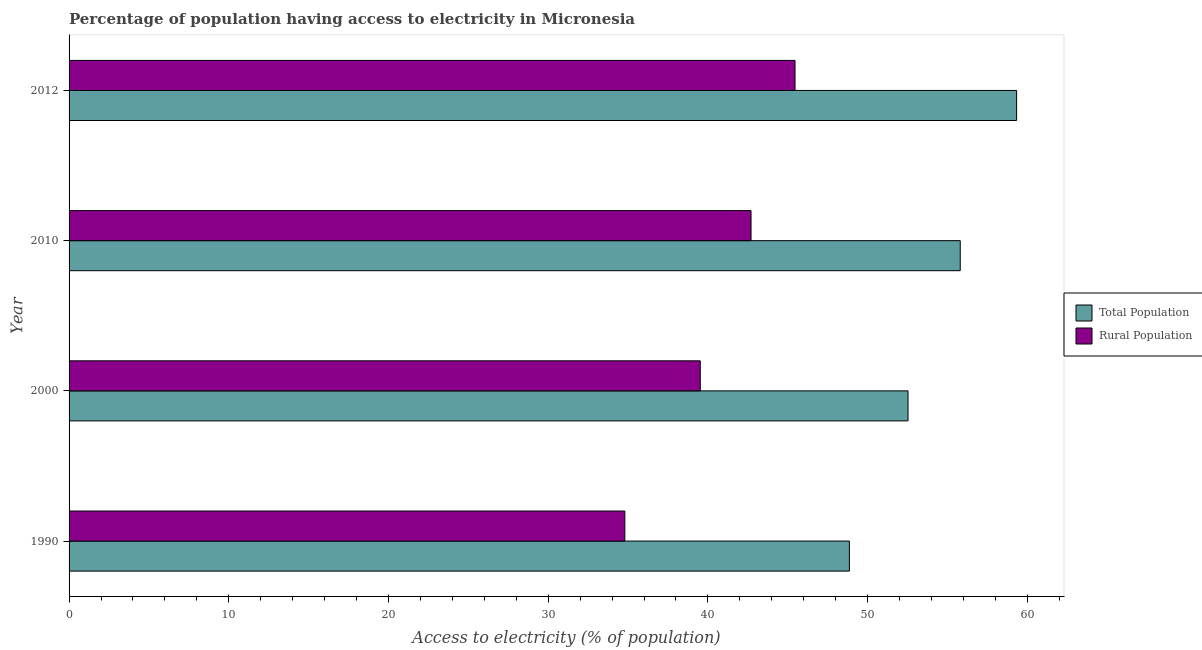How many different coloured bars are there?
Make the answer very short. 2. How many groups of bars are there?
Keep it short and to the point. 4. Are the number of bars on each tick of the Y-axis equal?
Offer a very short reply. Yes. How many bars are there on the 1st tick from the bottom?
Your answer should be very brief. 2. What is the label of the 4th group of bars from the top?
Your answer should be very brief. 1990. What is the percentage of population having access to electricity in 2012?
Offer a terse response. 59.33. Across all years, what is the maximum percentage of rural population having access to electricity?
Offer a very short reply. 45.45. Across all years, what is the minimum percentage of rural population having access to electricity?
Keep it short and to the point. 34.8. What is the total percentage of rural population having access to electricity in the graph?
Your answer should be compact. 162.47. What is the difference between the percentage of population having access to electricity in 2000 and that in 2010?
Provide a succinct answer. -3.27. What is the difference between the percentage of population having access to electricity in 2000 and the percentage of rural population having access to electricity in 2012?
Make the answer very short. 7.08. What is the average percentage of population having access to electricity per year?
Keep it short and to the point. 54.13. In the year 2012, what is the difference between the percentage of population having access to electricity and percentage of rural population having access to electricity?
Keep it short and to the point. 13.87. In how many years, is the percentage of population having access to electricity greater than 12 %?
Your answer should be compact. 4. What is the ratio of the percentage of population having access to electricity in 1990 to that in 2012?
Your response must be concise. 0.82. Is the percentage of rural population having access to electricity in 2000 less than that in 2012?
Provide a succinct answer. Yes. What is the difference between the highest and the second highest percentage of population having access to electricity?
Your response must be concise. 3.53. What is the difference between the highest and the lowest percentage of population having access to electricity?
Make the answer very short. 10.47. What does the 1st bar from the top in 1990 represents?
Offer a terse response. Rural Population. What does the 2nd bar from the bottom in 2012 represents?
Keep it short and to the point. Rural Population. How many bars are there?
Make the answer very short. 8. How many years are there in the graph?
Make the answer very short. 4. Are the values on the major ticks of X-axis written in scientific E-notation?
Your response must be concise. No. Where does the legend appear in the graph?
Ensure brevity in your answer.  Center right. How many legend labels are there?
Offer a terse response. 2. What is the title of the graph?
Your answer should be compact. Percentage of population having access to electricity in Micronesia. Does "Taxes" appear as one of the legend labels in the graph?
Give a very brief answer. No. What is the label or title of the X-axis?
Provide a short and direct response. Access to electricity (% of population). What is the label or title of the Y-axis?
Provide a succinct answer. Year. What is the Access to electricity (% of population) of Total Population in 1990?
Your response must be concise. 48.86. What is the Access to electricity (% of population) in Rural Population in 1990?
Offer a very short reply. 34.8. What is the Access to electricity (% of population) of Total Population in 2000?
Ensure brevity in your answer.  52.53. What is the Access to electricity (% of population) in Rural Population in 2000?
Offer a very short reply. 39.52. What is the Access to electricity (% of population) of Total Population in 2010?
Your answer should be very brief. 55.8. What is the Access to electricity (% of population) in Rural Population in 2010?
Offer a terse response. 42.7. What is the Access to electricity (% of population) of Total Population in 2012?
Give a very brief answer. 59.33. What is the Access to electricity (% of population) of Rural Population in 2012?
Give a very brief answer. 45.45. Across all years, what is the maximum Access to electricity (% of population) in Total Population?
Your answer should be very brief. 59.33. Across all years, what is the maximum Access to electricity (% of population) in Rural Population?
Offer a very short reply. 45.45. Across all years, what is the minimum Access to electricity (% of population) of Total Population?
Your response must be concise. 48.86. Across all years, what is the minimum Access to electricity (% of population) of Rural Population?
Your answer should be compact. 34.8. What is the total Access to electricity (% of population) of Total Population in the graph?
Ensure brevity in your answer.  216.52. What is the total Access to electricity (% of population) of Rural Population in the graph?
Your answer should be compact. 162.47. What is the difference between the Access to electricity (% of population) of Total Population in 1990 and that in 2000?
Provide a succinct answer. -3.67. What is the difference between the Access to electricity (% of population) in Rural Population in 1990 and that in 2000?
Provide a short and direct response. -4.72. What is the difference between the Access to electricity (% of population) in Total Population in 1990 and that in 2010?
Give a very brief answer. -6.94. What is the difference between the Access to electricity (% of population) of Rural Population in 1990 and that in 2010?
Offer a very short reply. -7.9. What is the difference between the Access to electricity (% of population) in Total Population in 1990 and that in 2012?
Keep it short and to the point. -10.47. What is the difference between the Access to electricity (% of population) in Rural Population in 1990 and that in 2012?
Provide a succinct answer. -10.66. What is the difference between the Access to electricity (% of population) in Total Population in 2000 and that in 2010?
Make the answer very short. -3.27. What is the difference between the Access to electricity (% of population) in Rural Population in 2000 and that in 2010?
Your answer should be very brief. -3.18. What is the difference between the Access to electricity (% of population) of Total Population in 2000 and that in 2012?
Give a very brief answer. -6.8. What is the difference between the Access to electricity (% of population) of Rural Population in 2000 and that in 2012?
Make the answer very short. -5.93. What is the difference between the Access to electricity (% of population) in Total Population in 2010 and that in 2012?
Make the answer very short. -3.53. What is the difference between the Access to electricity (% of population) of Rural Population in 2010 and that in 2012?
Provide a short and direct response. -2.75. What is the difference between the Access to electricity (% of population) in Total Population in 1990 and the Access to electricity (% of population) in Rural Population in 2000?
Keep it short and to the point. 9.34. What is the difference between the Access to electricity (% of population) of Total Population in 1990 and the Access to electricity (% of population) of Rural Population in 2010?
Offer a terse response. 6.16. What is the difference between the Access to electricity (% of population) of Total Population in 1990 and the Access to electricity (% of population) of Rural Population in 2012?
Keep it short and to the point. 3.4. What is the difference between the Access to electricity (% of population) in Total Population in 2000 and the Access to electricity (% of population) in Rural Population in 2010?
Keep it short and to the point. 9.83. What is the difference between the Access to electricity (% of population) in Total Population in 2000 and the Access to electricity (% of population) in Rural Population in 2012?
Your answer should be compact. 7.08. What is the difference between the Access to electricity (% of population) of Total Population in 2010 and the Access to electricity (% of population) of Rural Population in 2012?
Keep it short and to the point. 10.35. What is the average Access to electricity (% of population) of Total Population per year?
Make the answer very short. 54.13. What is the average Access to electricity (% of population) in Rural Population per year?
Provide a short and direct response. 40.62. In the year 1990, what is the difference between the Access to electricity (% of population) in Total Population and Access to electricity (% of population) in Rural Population?
Your response must be concise. 14.06. In the year 2000, what is the difference between the Access to electricity (% of population) of Total Population and Access to electricity (% of population) of Rural Population?
Ensure brevity in your answer.  13.01. In the year 2010, what is the difference between the Access to electricity (% of population) in Total Population and Access to electricity (% of population) in Rural Population?
Your answer should be very brief. 13.1. In the year 2012, what is the difference between the Access to electricity (% of population) of Total Population and Access to electricity (% of population) of Rural Population?
Offer a very short reply. 13.87. What is the ratio of the Access to electricity (% of population) of Total Population in 1990 to that in 2000?
Offer a very short reply. 0.93. What is the ratio of the Access to electricity (% of population) in Rural Population in 1990 to that in 2000?
Make the answer very short. 0.88. What is the ratio of the Access to electricity (% of population) in Total Population in 1990 to that in 2010?
Keep it short and to the point. 0.88. What is the ratio of the Access to electricity (% of population) in Rural Population in 1990 to that in 2010?
Provide a short and direct response. 0.81. What is the ratio of the Access to electricity (% of population) in Total Population in 1990 to that in 2012?
Offer a terse response. 0.82. What is the ratio of the Access to electricity (% of population) in Rural Population in 1990 to that in 2012?
Give a very brief answer. 0.77. What is the ratio of the Access to electricity (% of population) of Total Population in 2000 to that in 2010?
Give a very brief answer. 0.94. What is the ratio of the Access to electricity (% of population) of Rural Population in 2000 to that in 2010?
Provide a short and direct response. 0.93. What is the ratio of the Access to electricity (% of population) in Total Population in 2000 to that in 2012?
Your answer should be compact. 0.89. What is the ratio of the Access to electricity (% of population) of Rural Population in 2000 to that in 2012?
Keep it short and to the point. 0.87. What is the ratio of the Access to electricity (% of population) in Total Population in 2010 to that in 2012?
Ensure brevity in your answer.  0.94. What is the ratio of the Access to electricity (% of population) in Rural Population in 2010 to that in 2012?
Provide a short and direct response. 0.94. What is the difference between the highest and the second highest Access to electricity (% of population) of Total Population?
Ensure brevity in your answer.  3.53. What is the difference between the highest and the second highest Access to electricity (% of population) in Rural Population?
Make the answer very short. 2.75. What is the difference between the highest and the lowest Access to electricity (% of population) of Total Population?
Your answer should be compact. 10.47. What is the difference between the highest and the lowest Access to electricity (% of population) of Rural Population?
Give a very brief answer. 10.66. 